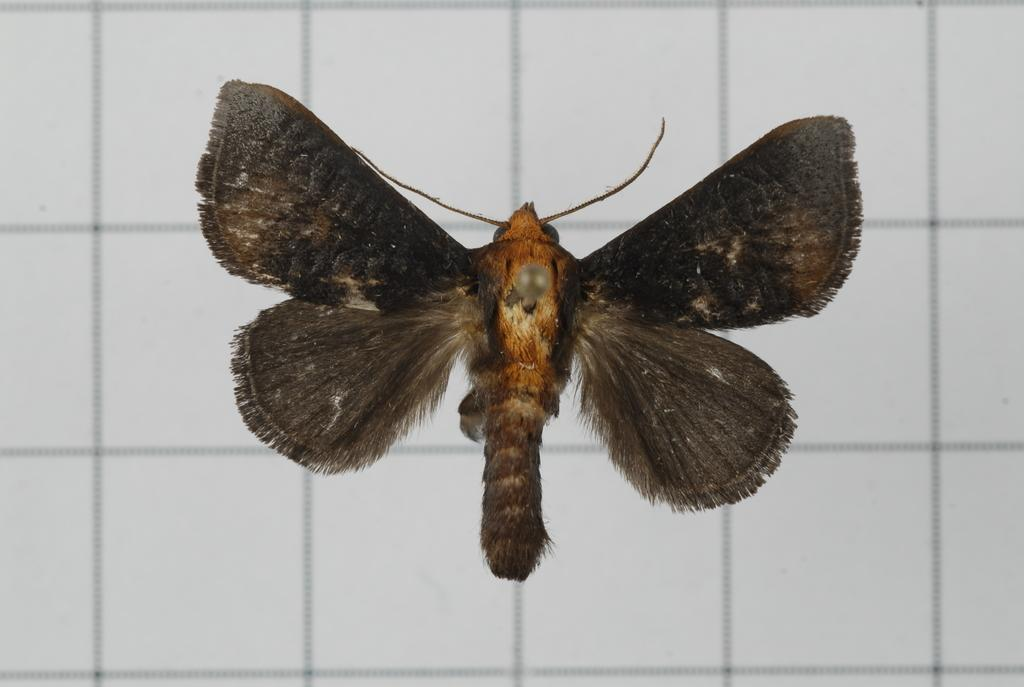What type of creature can be seen in the image? There is an insect in the picture. What color is the background of the image? The background of the image is white in color. What type of town is depicted in the image? There is no town present in the image; it features an insect and a white background. What kind of glove can be seen in the image? There is no glove present in the image. 